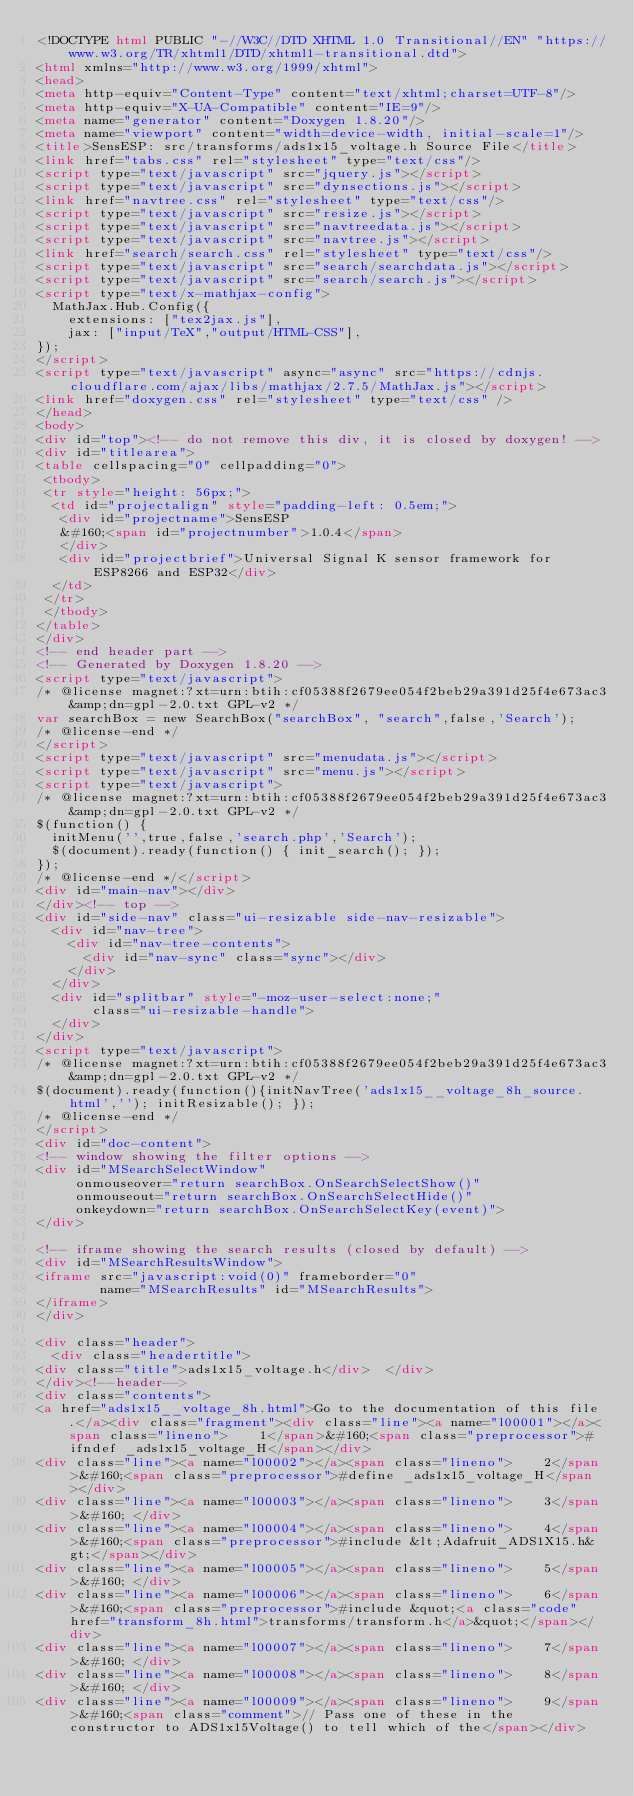<code> <loc_0><loc_0><loc_500><loc_500><_HTML_><!DOCTYPE html PUBLIC "-//W3C//DTD XHTML 1.0 Transitional//EN" "https://www.w3.org/TR/xhtml1/DTD/xhtml1-transitional.dtd">
<html xmlns="http://www.w3.org/1999/xhtml">
<head>
<meta http-equiv="Content-Type" content="text/xhtml;charset=UTF-8"/>
<meta http-equiv="X-UA-Compatible" content="IE=9"/>
<meta name="generator" content="Doxygen 1.8.20"/>
<meta name="viewport" content="width=device-width, initial-scale=1"/>
<title>SensESP: src/transforms/ads1x15_voltage.h Source File</title>
<link href="tabs.css" rel="stylesheet" type="text/css"/>
<script type="text/javascript" src="jquery.js"></script>
<script type="text/javascript" src="dynsections.js"></script>
<link href="navtree.css" rel="stylesheet" type="text/css"/>
<script type="text/javascript" src="resize.js"></script>
<script type="text/javascript" src="navtreedata.js"></script>
<script type="text/javascript" src="navtree.js"></script>
<link href="search/search.css" rel="stylesheet" type="text/css"/>
<script type="text/javascript" src="search/searchdata.js"></script>
<script type="text/javascript" src="search/search.js"></script>
<script type="text/x-mathjax-config">
  MathJax.Hub.Config({
    extensions: ["tex2jax.js"],
    jax: ["input/TeX","output/HTML-CSS"],
});
</script>
<script type="text/javascript" async="async" src="https://cdnjs.cloudflare.com/ajax/libs/mathjax/2.7.5/MathJax.js"></script>
<link href="doxygen.css" rel="stylesheet" type="text/css" />
</head>
<body>
<div id="top"><!-- do not remove this div, it is closed by doxygen! -->
<div id="titlearea">
<table cellspacing="0" cellpadding="0">
 <tbody>
 <tr style="height: 56px;">
  <td id="projectalign" style="padding-left: 0.5em;">
   <div id="projectname">SensESP
   &#160;<span id="projectnumber">1.0.4</span>
   </div>
   <div id="projectbrief">Universal Signal K sensor framework for ESP8266 and ESP32</div>
  </td>
 </tr>
 </tbody>
</table>
</div>
<!-- end header part -->
<!-- Generated by Doxygen 1.8.20 -->
<script type="text/javascript">
/* @license magnet:?xt=urn:btih:cf05388f2679ee054f2beb29a391d25f4e673ac3&amp;dn=gpl-2.0.txt GPL-v2 */
var searchBox = new SearchBox("searchBox", "search",false,'Search');
/* @license-end */
</script>
<script type="text/javascript" src="menudata.js"></script>
<script type="text/javascript" src="menu.js"></script>
<script type="text/javascript">
/* @license magnet:?xt=urn:btih:cf05388f2679ee054f2beb29a391d25f4e673ac3&amp;dn=gpl-2.0.txt GPL-v2 */
$(function() {
  initMenu('',true,false,'search.php','Search');
  $(document).ready(function() { init_search(); });
});
/* @license-end */</script>
<div id="main-nav"></div>
</div><!-- top -->
<div id="side-nav" class="ui-resizable side-nav-resizable">
  <div id="nav-tree">
    <div id="nav-tree-contents">
      <div id="nav-sync" class="sync"></div>
    </div>
  </div>
  <div id="splitbar" style="-moz-user-select:none;" 
       class="ui-resizable-handle">
  </div>
</div>
<script type="text/javascript">
/* @license magnet:?xt=urn:btih:cf05388f2679ee054f2beb29a391d25f4e673ac3&amp;dn=gpl-2.0.txt GPL-v2 */
$(document).ready(function(){initNavTree('ads1x15__voltage_8h_source.html',''); initResizable(); });
/* @license-end */
</script>
<div id="doc-content">
<!-- window showing the filter options -->
<div id="MSearchSelectWindow"
     onmouseover="return searchBox.OnSearchSelectShow()"
     onmouseout="return searchBox.OnSearchSelectHide()"
     onkeydown="return searchBox.OnSearchSelectKey(event)">
</div>

<!-- iframe showing the search results (closed by default) -->
<div id="MSearchResultsWindow">
<iframe src="javascript:void(0)" frameborder="0" 
        name="MSearchResults" id="MSearchResults">
</iframe>
</div>

<div class="header">
  <div class="headertitle">
<div class="title">ads1x15_voltage.h</div>  </div>
</div><!--header-->
<div class="contents">
<a href="ads1x15__voltage_8h.html">Go to the documentation of this file.</a><div class="fragment"><div class="line"><a name="l00001"></a><span class="lineno">    1</span>&#160;<span class="preprocessor">#ifndef _ads1x15_voltage_H</span></div>
<div class="line"><a name="l00002"></a><span class="lineno">    2</span>&#160;<span class="preprocessor">#define _ads1x15_voltage_H</span></div>
<div class="line"><a name="l00003"></a><span class="lineno">    3</span>&#160; </div>
<div class="line"><a name="l00004"></a><span class="lineno">    4</span>&#160;<span class="preprocessor">#include &lt;Adafruit_ADS1X15.h&gt;</span></div>
<div class="line"><a name="l00005"></a><span class="lineno">    5</span>&#160; </div>
<div class="line"><a name="l00006"></a><span class="lineno">    6</span>&#160;<span class="preprocessor">#include &quot;<a class="code" href="transform_8h.html">transforms/transform.h</a>&quot;</span></div>
<div class="line"><a name="l00007"></a><span class="lineno">    7</span>&#160; </div>
<div class="line"><a name="l00008"></a><span class="lineno">    8</span>&#160; </div>
<div class="line"><a name="l00009"></a><span class="lineno">    9</span>&#160;<span class="comment">// Pass one of these in the constructor to ADS1x15Voltage() to tell which of the</span></div></code> 